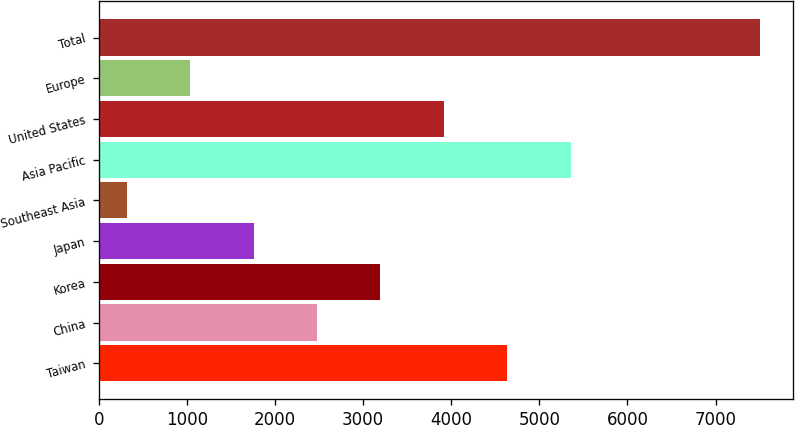Convert chart to OTSL. <chart><loc_0><loc_0><loc_500><loc_500><bar_chart><fcel>Taiwan<fcel>China<fcel>Korea<fcel>Japan<fcel>Southeast Asia<fcel>Asia Pacific<fcel>United States<fcel>Europe<fcel>Total<nl><fcel>4633.4<fcel>2476.7<fcel>3195.6<fcel>1757.8<fcel>320<fcel>5356<fcel>3914.5<fcel>1038.9<fcel>7509<nl></chart> 